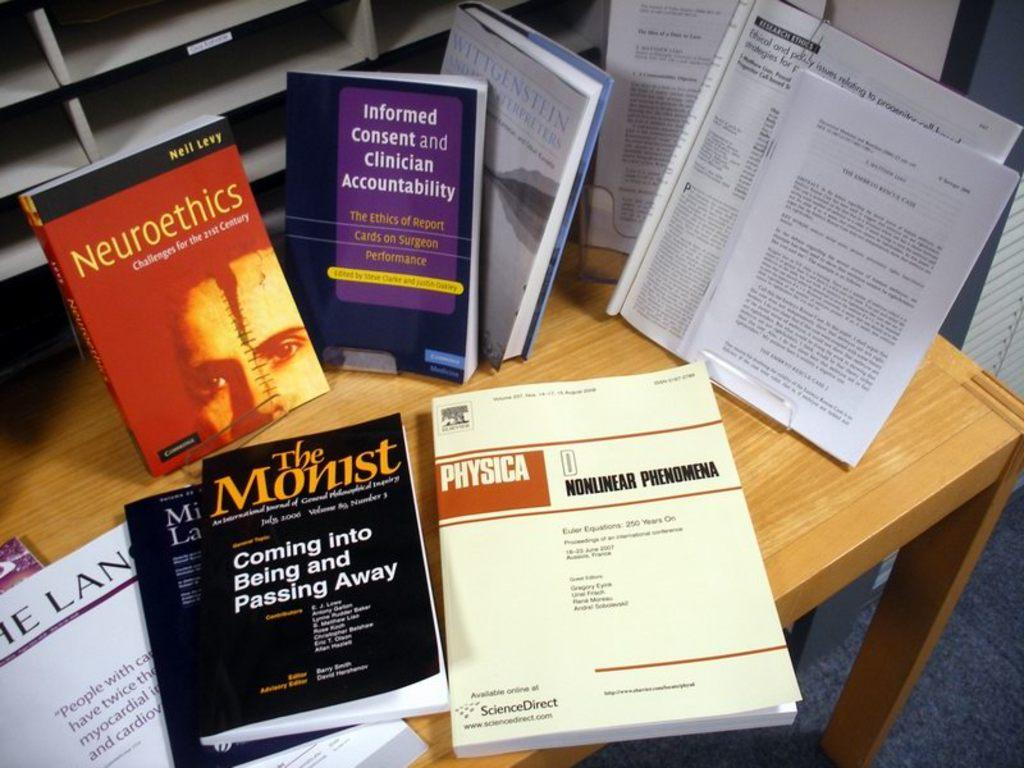<image>
Present a compact description of the photo's key features. Books including The Monist are arranged on a table. 